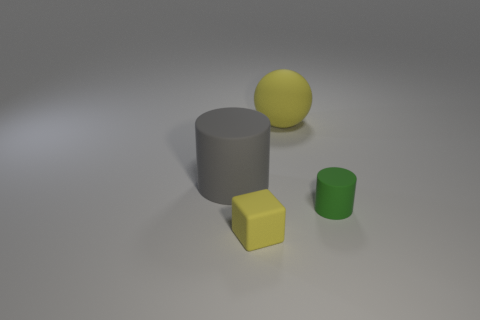Can you tell me what objects in the image could be used to demonstrate basic geometry concepts? Certainly! The image shows geometric shapes that are perfect for illustrating basic geometry concepts. The yellow cube represents a three-dimensional square with six equal faces, the large matte gray cylinder is an ideal example of a three-dimensionally extended circle, and the green cup showcases a cylinder with its top open, thus reflecting surface and volume concepts. Lastly, the yellow rubber sphere demonstrates the properties of a sphere with a uniform surface all around. 